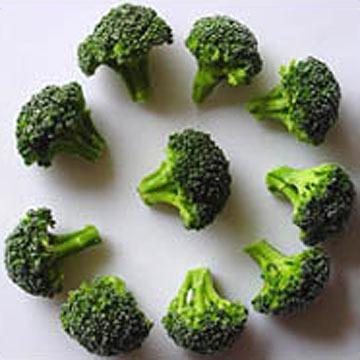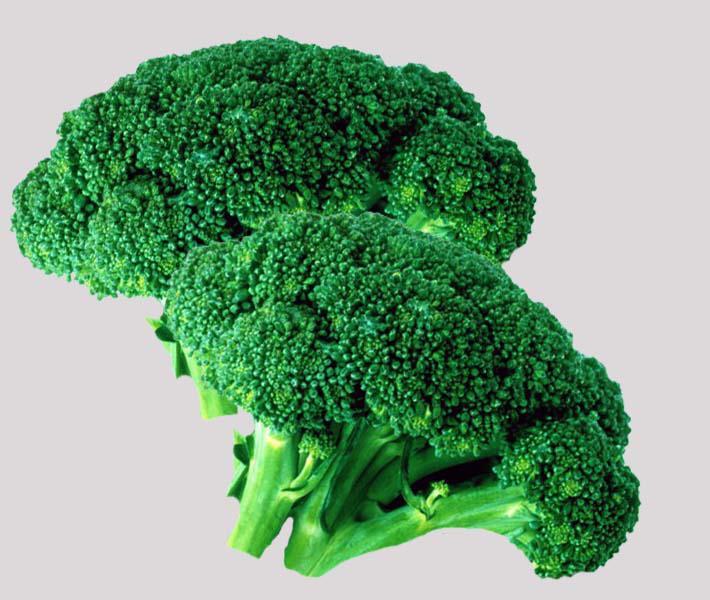The first image is the image on the left, the second image is the image on the right. For the images displayed, is the sentence "The broccoli on the right is a brighter green than on the left." factually correct? Answer yes or no. Yes. The first image is the image on the left, the second image is the image on the right. For the images displayed, is the sentence "No image contains more than five cut pieces of broccoli." factually correct? Answer yes or no. No. 